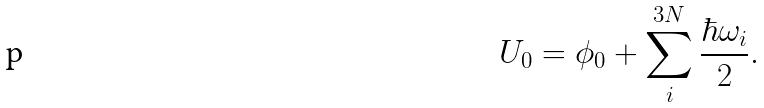<formula> <loc_0><loc_0><loc_500><loc_500>U _ { 0 } = \phi _ { 0 } + \sum _ { i } ^ { 3 N } \frac { \hbar { \omega } _ { i } } { 2 } .</formula> 